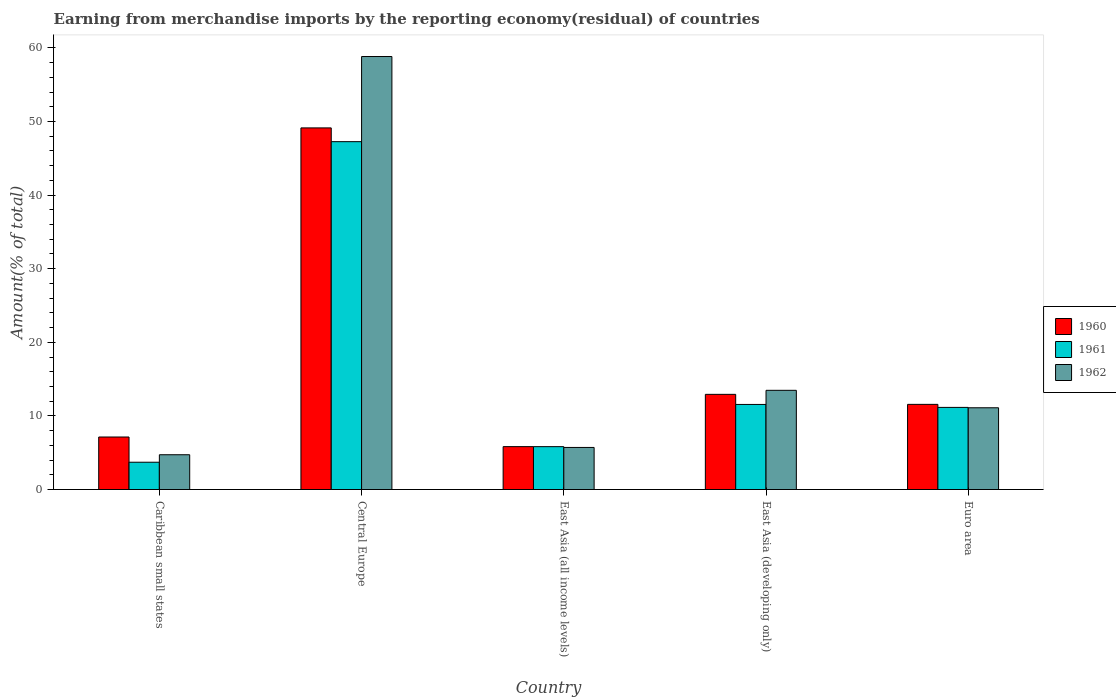How many different coloured bars are there?
Keep it short and to the point. 3. How many bars are there on the 2nd tick from the right?
Ensure brevity in your answer.  3. What is the label of the 5th group of bars from the left?
Provide a succinct answer. Euro area. What is the percentage of amount earned from merchandise imports in 1962 in Central Europe?
Ensure brevity in your answer.  58.82. Across all countries, what is the maximum percentage of amount earned from merchandise imports in 1961?
Your answer should be very brief. 47.26. Across all countries, what is the minimum percentage of amount earned from merchandise imports in 1960?
Your response must be concise. 5.83. In which country was the percentage of amount earned from merchandise imports in 1961 maximum?
Your response must be concise. Central Europe. In which country was the percentage of amount earned from merchandise imports in 1960 minimum?
Your answer should be compact. East Asia (all income levels). What is the total percentage of amount earned from merchandise imports in 1960 in the graph?
Give a very brief answer. 86.58. What is the difference between the percentage of amount earned from merchandise imports in 1961 in East Asia (all income levels) and that in East Asia (developing only)?
Keep it short and to the point. -5.73. What is the difference between the percentage of amount earned from merchandise imports in 1960 in Caribbean small states and the percentage of amount earned from merchandise imports in 1962 in Euro area?
Your answer should be compact. -3.97. What is the average percentage of amount earned from merchandise imports in 1962 per country?
Provide a short and direct response. 18.77. What is the difference between the percentage of amount earned from merchandise imports of/in 1961 and percentage of amount earned from merchandise imports of/in 1962 in East Asia (all income levels)?
Your answer should be compact. 0.11. What is the ratio of the percentage of amount earned from merchandise imports in 1960 in East Asia (all income levels) to that in Euro area?
Your answer should be compact. 0.5. What is the difference between the highest and the second highest percentage of amount earned from merchandise imports in 1960?
Keep it short and to the point. 37.56. What is the difference between the highest and the lowest percentage of amount earned from merchandise imports in 1962?
Offer a terse response. 54.1. In how many countries, is the percentage of amount earned from merchandise imports in 1960 greater than the average percentage of amount earned from merchandise imports in 1960 taken over all countries?
Offer a terse response. 1. Is the sum of the percentage of amount earned from merchandise imports in 1961 in Caribbean small states and Euro area greater than the maximum percentage of amount earned from merchandise imports in 1962 across all countries?
Ensure brevity in your answer.  No. What does the 1st bar from the right in East Asia (developing only) represents?
Provide a succinct answer. 1962. How many bars are there?
Offer a terse response. 15. How many countries are there in the graph?
Keep it short and to the point. 5. What is the difference between two consecutive major ticks on the Y-axis?
Your answer should be very brief. 10. Are the values on the major ticks of Y-axis written in scientific E-notation?
Your answer should be compact. No. Does the graph contain grids?
Your answer should be very brief. No. Where does the legend appear in the graph?
Make the answer very short. Center right. What is the title of the graph?
Provide a short and direct response. Earning from merchandise imports by the reporting economy(residual) of countries. What is the label or title of the X-axis?
Keep it short and to the point. Country. What is the label or title of the Y-axis?
Make the answer very short. Amount(% of total). What is the Amount(% of total) of 1960 in Caribbean small states?
Keep it short and to the point. 7.13. What is the Amount(% of total) in 1961 in Caribbean small states?
Give a very brief answer. 3.71. What is the Amount(% of total) of 1962 in Caribbean small states?
Make the answer very short. 4.72. What is the Amount(% of total) of 1960 in Central Europe?
Give a very brief answer. 49.12. What is the Amount(% of total) in 1961 in Central Europe?
Your answer should be compact. 47.26. What is the Amount(% of total) in 1962 in Central Europe?
Your answer should be compact. 58.82. What is the Amount(% of total) in 1960 in East Asia (all income levels)?
Your response must be concise. 5.83. What is the Amount(% of total) of 1961 in East Asia (all income levels)?
Provide a short and direct response. 5.82. What is the Amount(% of total) of 1962 in East Asia (all income levels)?
Your response must be concise. 5.72. What is the Amount(% of total) of 1960 in East Asia (developing only)?
Offer a terse response. 12.93. What is the Amount(% of total) of 1961 in East Asia (developing only)?
Ensure brevity in your answer.  11.56. What is the Amount(% of total) in 1962 in East Asia (developing only)?
Offer a terse response. 13.48. What is the Amount(% of total) in 1960 in Euro area?
Your response must be concise. 11.57. What is the Amount(% of total) in 1961 in Euro area?
Offer a terse response. 11.16. What is the Amount(% of total) in 1962 in Euro area?
Give a very brief answer. 11.1. Across all countries, what is the maximum Amount(% of total) in 1960?
Provide a short and direct response. 49.12. Across all countries, what is the maximum Amount(% of total) in 1961?
Provide a succinct answer. 47.26. Across all countries, what is the maximum Amount(% of total) in 1962?
Give a very brief answer. 58.82. Across all countries, what is the minimum Amount(% of total) in 1960?
Keep it short and to the point. 5.83. Across all countries, what is the minimum Amount(% of total) of 1961?
Keep it short and to the point. 3.71. Across all countries, what is the minimum Amount(% of total) in 1962?
Your answer should be compact. 4.72. What is the total Amount(% of total) in 1960 in the graph?
Your answer should be compact. 86.58. What is the total Amount(% of total) of 1961 in the graph?
Offer a very short reply. 79.5. What is the total Amount(% of total) in 1962 in the graph?
Provide a short and direct response. 93.84. What is the difference between the Amount(% of total) in 1960 in Caribbean small states and that in Central Europe?
Provide a short and direct response. -41.99. What is the difference between the Amount(% of total) of 1961 in Caribbean small states and that in Central Europe?
Offer a very short reply. -43.55. What is the difference between the Amount(% of total) in 1962 in Caribbean small states and that in Central Europe?
Your response must be concise. -54.1. What is the difference between the Amount(% of total) of 1960 in Caribbean small states and that in East Asia (all income levels)?
Keep it short and to the point. 1.31. What is the difference between the Amount(% of total) in 1961 in Caribbean small states and that in East Asia (all income levels)?
Offer a very short reply. -2.12. What is the difference between the Amount(% of total) of 1962 in Caribbean small states and that in East Asia (all income levels)?
Offer a very short reply. -0.99. What is the difference between the Amount(% of total) of 1960 in Caribbean small states and that in East Asia (developing only)?
Give a very brief answer. -5.79. What is the difference between the Amount(% of total) of 1961 in Caribbean small states and that in East Asia (developing only)?
Offer a very short reply. -7.85. What is the difference between the Amount(% of total) of 1962 in Caribbean small states and that in East Asia (developing only)?
Provide a succinct answer. -8.75. What is the difference between the Amount(% of total) of 1960 in Caribbean small states and that in Euro area?
Offer a terse response. -4.43. What is the difference between the Amount(% of total) of 1961 in Caribbean small states and that in Euro area?
Give a very brief answer. -7.45. What is the difference between the Amount(% of total) of 1962 in Caribbean small states and that in Euro area?
Your answer should be very brief. -6.38. What is the difference between the Amount(% of total) in 1960 in Central Europe and that in East Asia (all income levels)?
Provide a succinct answer. 43.3. What is the difference between the Amount(% of total) in 1961 in Central Europe and that in East Asia (all income levels)?
Your response must be concise. 41.43. What is the difference between the Amount(% of total) of 1962 in Central Europe and that in East Asia (all income levels)?
Your response must be concise. 53.1. What is the difference between the Amount(% of total) in 1960 in Central Europe and that in East Asia (developing only)?
Keep it short and to the point. 36.2. What is the difference between the Amount(% of total) in 1961 in Central Europe and that in East Asia (developing only)?
Give a very brief answer. 35.7. What is the difference between the Amount(% of total) in 1962 in Central Europe and that in East Asia (developing only)?
Give a very brief answer. 45.34. What is the difference between the Amount(% of total) in 1960 in Central Europe and that in Euro area?
Make the answer very short. 37.56. What is the difference between the Amount(% of total) in 1961 in Central Europe and that in Euro area?
Make the answer very short. 36.1. What is the difference between the Amount(% of total) of 1962 in Central Europe and that in Euro area?
Offer a terse response. 47.72. What is the difference between the Amount(% of total) in 1960 in East Asia (all income levels) and that in East Asia (developing only)?
Your answer should be compact. -7.1. What is the difference between the Amount(% of total) in 1961 in East Asia (all income levels) and that in East Asia (developing only)?
Offer a very short reply. -5.73. What is the difference between the Amount(% of total) of 1962 in East Asia (all income levels) and that in East Asia (developing only)?
Give a very brief answer. -7.76. What is the difference between the Amount(% of total) of 1960 in East Asia (all income levels) and that in Euro area?
Offer a very short reply. -5.74. What is the difference between the Amount(% of total) of 1961 in East Asia (all income levels) and that in Euro area?
Offer a very short reply. -5.33. What is the difference between the Amount(% of total) in 1962 in East Asia (all income levels) and that in Euro area?
Your response must be concise. -5.39. What is the difference between the Amount(% of total) of 1960 in East Asia (developing only) and that in Euro area?
Give a very brief answer. 1.36. What is the difference between the Amount(% of total) in 1961 in East Asia (developing only) and that in Euro area?
Provide a succinct answer. 0.4. What is the difference between the Amount(% of total) of 1962 in East Asia (developing only) and that in Euro area?
Give a very brief answer. 2.37. What is the difference between the Amount(% of total) in 1960 in Caribbean small states and the Amount(% of total) in 1961 in Central Europe?
Make the answer very short. -40.12. What is the difference between the Amount(% of total) in 1960 in Caribbean small states and the Amount(% of total) in 1962 in Central Europe?
Keep it short and to the point. -51.69. What is the difference between the Amount(% of total) of 1961 in Caribbean small states and the Amount(% of total) of 1962 in Central Europe?
Your answer should be compact. -55.11. What is the difference between the Amount(% of total) of 1960 in Caribbean small states and the Amount(% of total) of 1961 in East Asia (all income levels)?
Your answer should be very brief. 1.31. What is the difference between the Amount(% of total) of 1960 in Caribbean small states and the Amount(% of total) of 1962 in East Asia (all income levels)?
Provide a succinct answer. 1.42. What is the difference between the Amount(% of total) of 1961 in Caribbean small states and the Amount(% of total) of 1962 in East Asia (all income levels)?
Ensure brevity in your answer.  -2.01. What is the difference between the Amount(% of total) of 1960 in Caribbean small states and the Amount(% of total) of 1961 in East Asia (developing only)?
Your answer should be compact. -4.42. What is the difference between the Amount(% of total) of 1960 in Caribbean small states and the Amount(% of total) of 1962 in East Asia (developing only)?
Make the answer very short. -6.34. What is the difference between the Amount(% of total) in 1961 in Caribbean small states and the Amount(% of total) in 1962 in East Asia (developing only)?
Your answer should be very brief. -9.77. What is the difference between the Amount(% of total) of 1960 in Caribbean small states and the Amount(% of total) of 1961 in Euro area?
Make the answer very short. -4.02. What is the difference between the Amount(% of total) of 1960 in Caribbean small states and the Amount(% of total) of 1962 in Euro area?
Your answer should be very brief. -3.97. What is the difference between the Amount(% of total) in 1961 in Caribbean small states and the Amount(% of total) in 1962 in Euro area?
Make the answer very short. -7.4. What is the difference between the Amount(% of total) of 1960 in Central Europe and the Amount(% of total) of 1961 in East Asia (all income levels)?
Your answer should be very brief. 43.3. What is the difference between the Amount(% of total) in 1960 in Central Europe and the Amount(% of total) in 1962 in East Asia (all income levels)?
Give a very brief answer. 43.41. What is the difference between the Amount(% of total) of 1961 in Central Europe and the Amount(% of total) of 1962 in East Asia (all income levels)?
Provide a short and direct response. 41.54. What is the difference between the Amount(% of total) in 1960 in Central Europe and the Amount(% of total) in 1961 in East Asia (developing only)?
Give a very brief answer. 37.57. What is the difference between the Amount(% of total) of 1960 in Central Europe and the Amount(% of total) of 1962 in East Asia (developing only)?
Provide a succinct answer. 35.65. What is the difference between the Amount(% of total) of 1961 in Central Europe and the Amount(% of total) of 1962 in East Asia (developing only)?
Provide a short and direct response. 33.78. What is the difference between the Amount(% of total) in 1960 in Central Europe and the Amount(% of total) in 1961 in Euro area?
Your answer should be compact. 37.97. What is the difference between the Amount(% of total) of 1960 in Central Europe and the Amount(% of total) of 1962 in Euro area?
Offer a very short reply. 38.02. What is the difference between the Amount(% of total) of 1961 in Central Europe and the Amount(% of total) of 1962 in Euro area?
Make the answer very short. 36.15. What is the difference between the Amount(% of total) in 1960 in East Asia (all income levels) and the Amount(% of total) in 1961 in East Asia (developing only)?
Ensure brevity in your answer.  -5.73. What is the difference between the Amount(% of total) in 1960 in East Asia (all income levels) and the Amount(% of total) in 1962 in East Asia (developing only)?
Offer a very short reply. -7.65. What is the difference between the Amount(% of total) in 1961 in East Asia (all income levels) and the Amount(% of total) in 1962 in East Asia (developing only)?
Make the answer very short. -7.65. What is the difference between the Amount(% of total) in 1960 in East Asia (all income levels) and the Amount(% of total) in 1961 in Euro area?
Your response must be concise. -5.33. What is the difference between the Amount(% of total) of 1960 in East Asia (all income levels) and the Amount(% of total) of 1962 in Euro area?
Offer a very short reply. -5.28. What is the difference between the Amount(% of total) of 1961 in East Asia (all income levels) and the Amount(% of total) of 1962 in Euro area?
Offer a very short reply. -5.28. What is the difference between the Amount(% of total) in 1960 in East Asia (developing only) and the Amount(% of total) in 1961 in Euro area?
Provide a succinct answer. 1.77. What is the difference between the Amount(% of total) in 1960 in East Asia (developing only) and the Amount(% of total) in 1962 in Euro area?
Provide a succinct answer. 1.82. What is the difference between the Amount(% of total) in 1961 in East Asia (developing only) and the Amount(% of total) in 1962 in Euro area?
Provide a succinct answer. 0.45. What is the average Amount(% of total) in 1960 per country?
Your answer should be very brief. 17.32. What is the average Amount(% of total) in 1961 per country?
Ensure brevity in your answer.  15.9. What is the average Amount(% of total) of 1962 per country?
Your answer should be very brief. 18.77. What is the difference between the Amount(% of total) of 1960 and Amount(% of total) of 1961 in Caribbean small states?
Offer a terse response. 3.43. What is the difference between the Amount(% of total) of 1960 and Amount(% of total) of 1962 in Caribbean small states?
Keep it short and to the point. 2.41. What is the difference between the Amount(% of total) of 1961 and Amount(% of total) of 1962 in Caribbean small states?
Give a very brief answer. -1.02. What is the difference between the Amount(% of total) of 1960 and Amount(% of total) of 1961 in Central Europe?
Offer a terse response. 1.87. What is the difference between the Amount(% of total) of 1960 and Amount(% of total) of 1962 in Central Europe?
Provide a succinct answer. -9.7. What is the difference between the Amount(% of total) of 1961 and Amount(% of total) of 1962 in Central Europe?
Ensure brevity in your answer.  -11.56. What is the difference between the Amount(% of total) in 1960 and Amount(% of total) in 1961 in East Asia (all income levels)?
Provide a short and direct response. 0. What is the difference between the Amount(% of total) in 1960 and Amount(% of total) in 1962 in East Asia (all income levels)?
Provide a succinct answer. 0.11. What is the difference between the Amount(% of total) in 1961 and Amount(% of total) in 1962 in East Asia (all income levels)?
Keep it short and to the point. 0.11. What is the difference between the Amount(% of total) in 1960 and Amount(% of total) in 1961 in East Asia (developing only)?
Make the answer very short. 1.37. What is the difference between the Amount(% of total) in 1960 and Amount(% of total) in 1962 in East Asia (developing only)?
Your answer should be compact. -0.55. What is the difference between the Amount(% of total) of 1961 and Amount(% of total) of 1962 in East Asia (developing only)?
Your answer should be compact. -1.92. What is the difference between the Amount(% of total) of 1960 and Amount(% of total) of 1961 in Euro area?
Provide a succinct answer. 0.41. What is the difference between the Amount(% of total) in 1960 and Amount(% of total) in 1962 in Euro area?
Ensure brevity in your answer.  0.46. What is the difference between the Amount(% of total) in 1961 and Amount(% of total) in 1962 in Euro area?
Keep it short and to the point. 0.05. What is the ratio of the Amount(% of total) of 1960 in Caribbean small states to that in Central Europe?
Offer a very short reply. 0.15. What is the ratio of the Amount(% of total) of 1961 in Caribbean small states to that in Central Europe?
Offer a very short reply. 0.08. What is the ratio of the Amount(% of total) of 1962 in Caribbean small states to that in Central Europe?
Provide a succinct answer. 0.08. What is the ratio of the Amount(% of total) of 1960 in Caribbean small states to that in East Asia (all income levels)?
Keep it short and to the point. 1.22. What is the ratio of the Amount(% of total) of 1961 in Caribbean small states to that in East Asia (all income levels)?
Offer a terse response. 0.64. What is the ratio of the Amount(% of total) in 1962 in Caribbean small states to that in East Asia (all income levels)?
Keep it short and to the point. 0.83. What is the ratio of the Amount(% of total) of 1960 in Caribbean small states to that in East Asia (developing only)?
Give a very brief answer. 0.55. What is the ratio of the Amount(% of total) in 1961 in Caribbean small states to that in East Asia (developing only)?
Offer a very short reply. 0.32. What is the ratio of the Amount(% of total) of 1962 in Caribbean small states to that in East Asia (developing only)?
Give a very brief answer. 0.35. What is the ratio of the Amount(% of total) of 1960 in Caribbean small states to that in Euro area?
Provide a succinct answer. 0.62. What is the ratio of the Amount(% of total) in 1961 in Caribbean small states to that in Euro area?
Give a very brief answer. 0.33. What is the ratio of the Amount(% of total) of 1962 in Caribbean small states to that in Euro area?
Make the answer very short. 0.43. What is the ratio of the Amount(% of total) of 1960 in Central Europe to that in East Asia (all income levels)?
Your answer should be compact. 8.43. What is the ratio of the Amount(% of total) in 1961 in Central Europe to that in East Asia (all income levels)?
Provide a succinct answer. 8.12. What is the ratio of the Amount(% of total) in 1962 in Central Europe to that in East Asia (all income levels)?
Your response must be concise. 10.29. What is the ratio of the Amount(% of total) in 1960 in Central Europe to that in East Asia (developing only)?
Offer a very short reply. 3.8. What is the ratio of the Amount(% of total) in 1961 in Central Europe to that in East Asia (developing only)?
Provide a succinct answer. 4.09. What is the ratio of the Amount(% of total) of 1962 in Central Europe to that in East Asia (developing only)?
Provide a short and direct response. 4.36. What is the ratio of the Amount(% of total) in 1960 in Central Europe to that in Euro area?
Keep it short and to the point. 4.25. What is the ratio of the Amount(% of total) in 1961 in Central Europe to that in Euro area?
Provide a short and direct response. 4.24. What is the ratio of the Amount(% of total) in 1962 in Central Europe to that in Euro area?
Offer a very short reply. 5.3. What is the ratio of the Amount(% of total) of 1960 in East Asia (all income levels) to that in East Asia (developing only)?
Your answer should be very brief. 0.45. What is the ratio of the Amount(% of total) of 1961 in East Asia (all income levels) to that in East Asia (developing only)?
Offer a terse response. 0.5. What is the ratio of the Amount(% of total) in 1962 in East Asia (all income levels) to that in East Asia (developing only)?
Offer a terse response. 0.42. What is the ratio of the Amount(% of total) in 1960 in East Asia (all income levels) to that in Euro area?
Ensure brevity in your answer.  0.5. What is the ratio of the Amount(% of total) of 1961 in East Asia (all income levels) to that in Euro area?
Provide a succinct answer. 0.52. What is the ratio of the Amount(% of total) of 1962 in East Asia (all income levels) to that in Euro area?
Provide a succinct answer. 0.51. What is the ratio of the Amount(% of total) in 1960 in East Asia (developing only) to that in Euro area?
Your response must be concise. 1.12. What is the ratio of the Amount(% of total) of 1961 in East Asia (developing only) to that in Euro area?
Provide a short and direct response. 1.04. What is the ratio of the Amount(% of total) of 1962 in East Asia (developing only) to that in Euro area?
Your answer should be compact. 1.21. What is the difference between the highest and the second highest Amount(% of total) of 1960?
Offer a terse response. 36.2. What is the difference between the highest and the second highest Amount(% of total) of 1961?
Provide a succinct answer. 35.7. What is the difference between the highest and the second highest Amount(% of total) in 1962?
Give a very brief answer. 45.34. What is the difference between the highest and the lowest Amount(% of total) in 1960?
Offer a very short reply. 43.3. What is the difference between the highest and the lowest Amount(% of total) in 1961?
Provide a succinct answer. 43.55. What is the difference between the highest and the lowest Amount(% of total) in 1962?
Offer a very short reply. 54.1. 